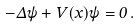<formula> <loc_0><loc_0><loc_500><loc_500>- \Delta \psi + V ( x ) \psi = 0 \, .</formula> 